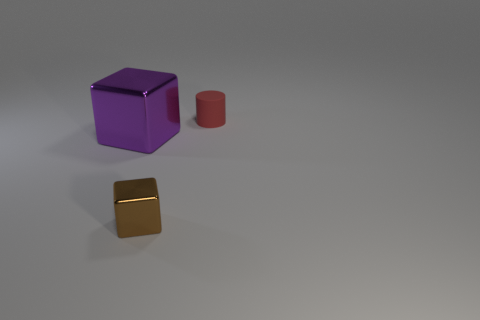Add 1 gray cubes. How many objects exist? 4 Subtract all blocks. How many objects are left? 1 Subtract all large blue matte cylinders. Subtract all red cylinders. How many objects are left? 2 Add 2 large purple metallic objects. How many large purple metallic objects are left? 3 Add 3 red cylinders. How many red cylinders exist? 4 Subtract 0 purple cylinders. How many objects are left? 3 